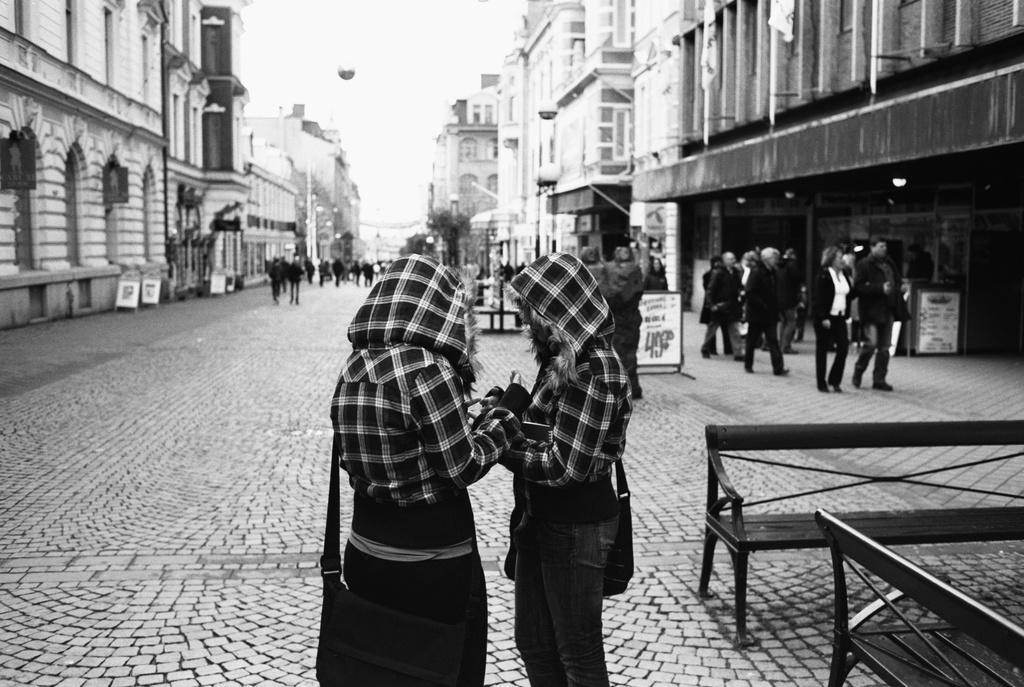Please provide a concise description of this image. In this image I can see the group of people on the road. On both sides of the road I can see the buildings and boards. To the right I can see the benches. I can see few people with bags. In the background I can see the sky and this is a black and white image. 